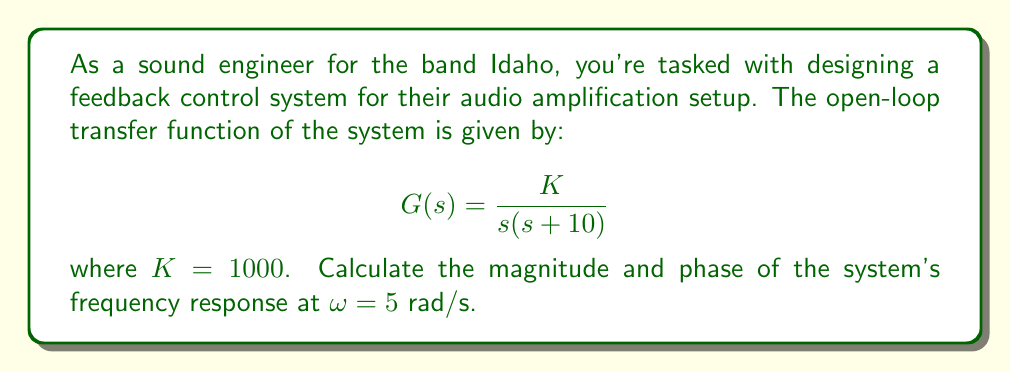Can you solve this math problem? To calculate the frequency response, we need to follow these steps:

1) The frequency response is obtained by substituting $s$ with $j\omega$ in the transfer function:

   $$G(j\omega) = \frac{K}{j\omega(j\omega+10)}$$

2) Substitute the given values:
   
   $$G(j5) = \frac{1000}{j5(j5+10)}$$

3) Simplify the denominator:
   
   $$G(j5) = \frac{1000}{j5(j5+10)} = \frac{1000}{-25+j50}$$

4) Convert to polar form:
   
   The magnitude of the denominator is $\sqrt{(-25)^2 + 50^2} = \sqrt{3125} = 55.90$
   
   The phase of the denominator is $\tan^{-1}(\frac{50}{-25}) = 2.034$ radians or 116.57°

5) Therefore, the frequency response in polar form is:

   $$G(j5) = \frac{1000}{55.90 \angle 116.57°} = 17.89 \angle -116.57°$$

6) The magnitude is 17.89, and the phase is -116.57°

To convert the phase to radians: $-116.57° \times \frac{\pi}{180°} = -2.034$ radians
Answer: Magnitude: 17.89
Phase: -2.034 radians or -116.57° 